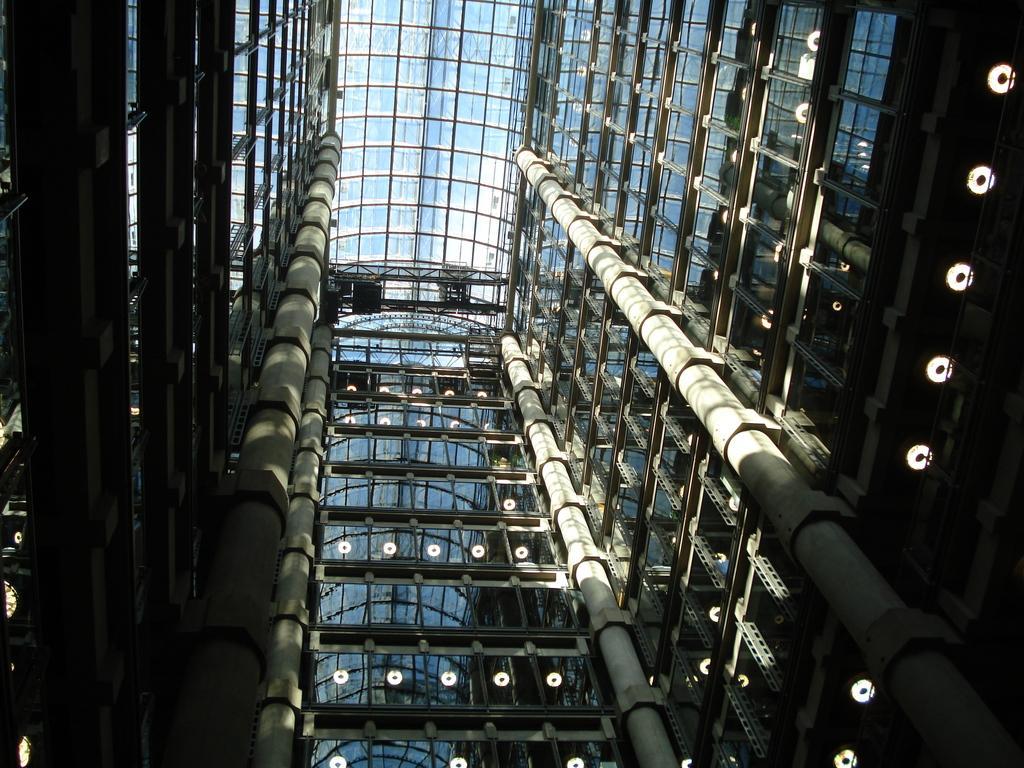Describe this image in one or two sentences. In this image I can see the inner part of the building and I can see few glass windows and few lights. 